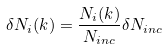Convert formula to latex. <formula><loc_0><loc_0><loc_500><loc_500>\delta N _ { i } ( k ) = \frac { N _ { i } ( k ) } { N _ { i n c } } \delta N _ { i n c }</formula> 